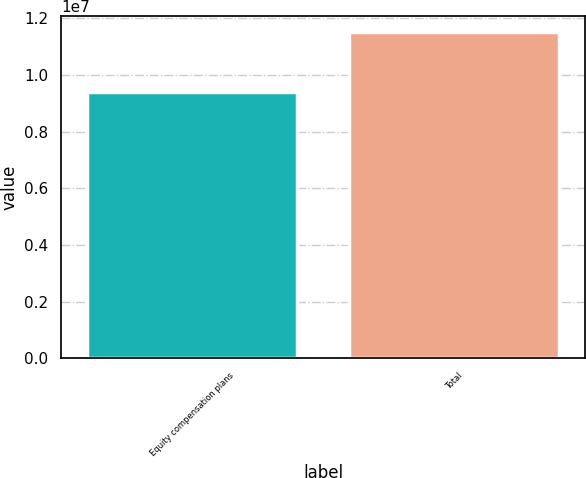Convert chart to OTSL. <chart><loc_0><loc_0><loc_500><loc_500><bar_chart><fcel>Equity compensation plans<fcel>Total<nl><fcel>9.41322e+06<fcel>1.15025e+07<nl></chart> 